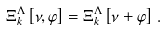<formula> <loc_0><loc_0><loc_500><loc_500>\Xi ^ { \Lambda } _ { k } \left [ \nu , \varphi \right ] = \Xi ^ { \Lambda } _ { k } \left [ \nu + \varphi \right ] \, .</formula> 